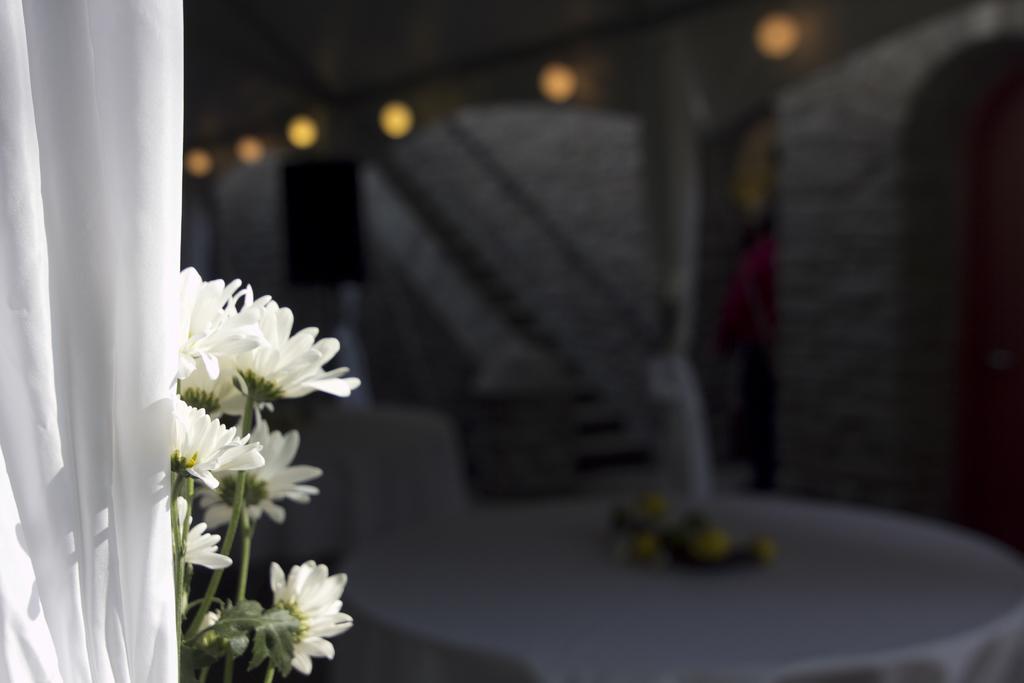Could you give a brief overview of what you see in this image? In this image we can see some flowers on the left side of the image and there is a cloth. We can see a table with some objects and there are some lights and the image is blurred on the right side. 